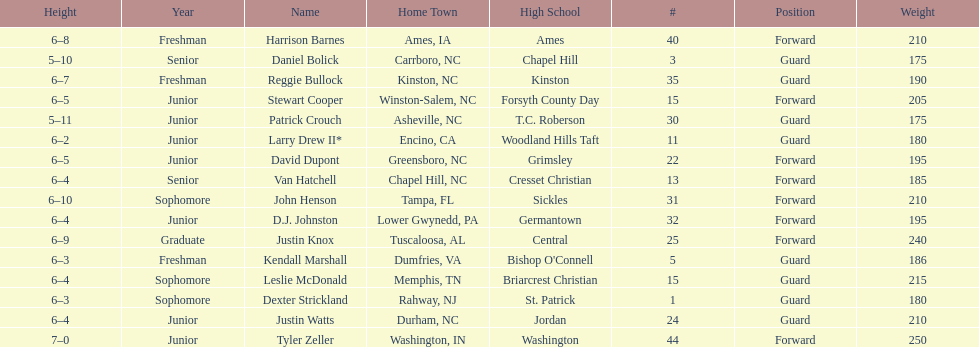Total number of players whose home town was in north carolina (nc) 7. 